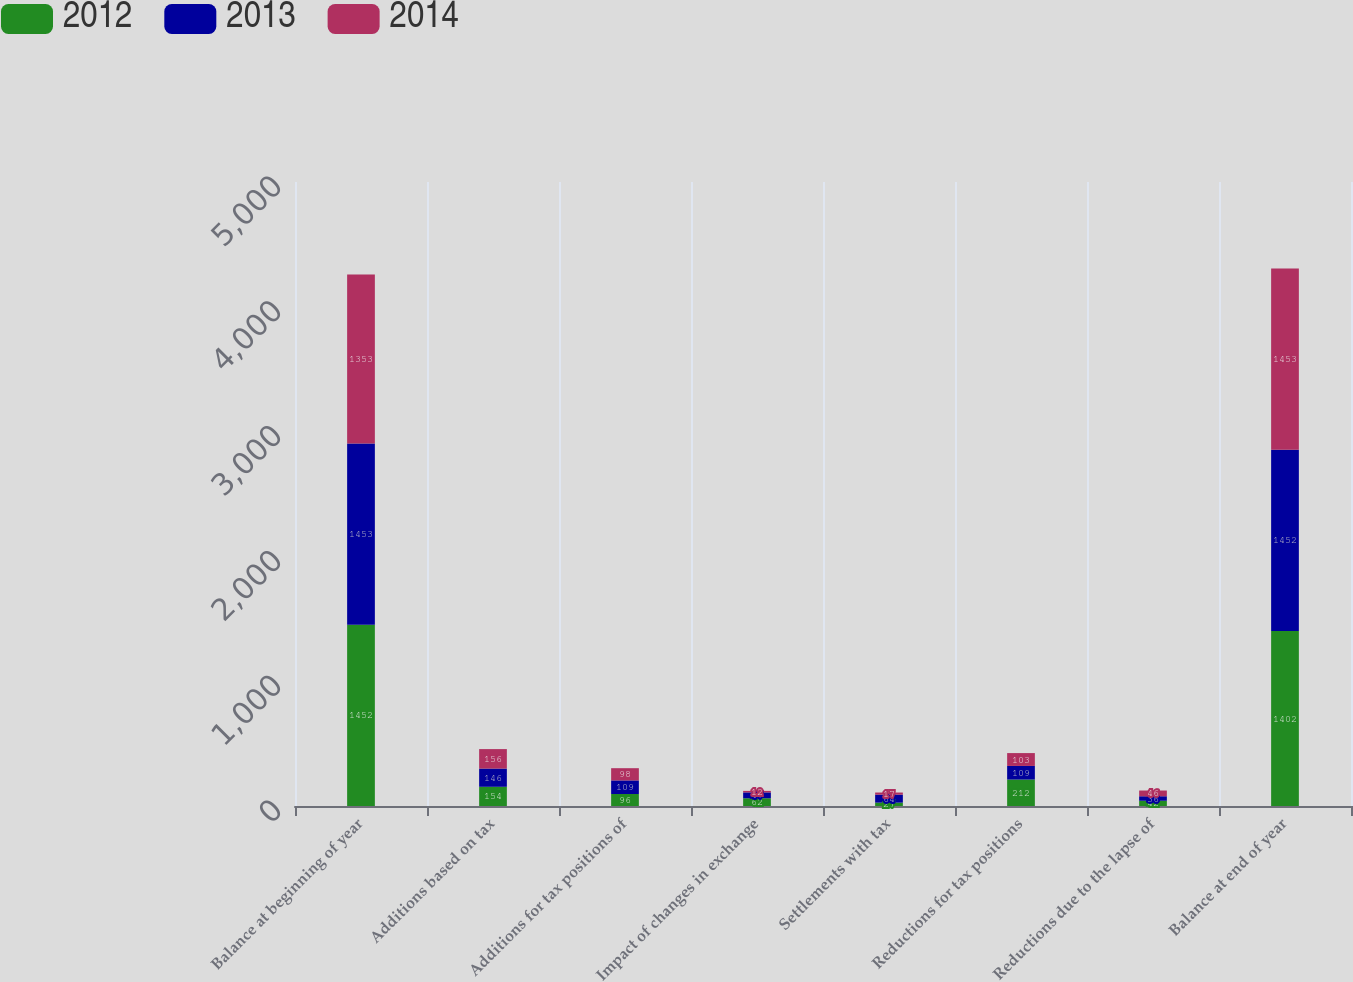Convert chart to OTSL. <chart><loc_0><loc_0><loc_500><loc_500><stacked_bar_chart><ecel><fcel>Balance at beginning of year<fcel>Additions based on tax<fcel>Additions for tax positions of<fcel>Impact of changes in exchange<fcel>Settlements with tax<fcel>Reductions for tax positions<fcel>Reductions due to the lapse of<fcel>Balance at end of year<nl><fcel>2012<fcel>1452<fcel>154<fcel>96<fcel>62<fcel>27<fcel>212<fcel>42<fcel>1402<nl><fcel>2013<fcel>1453<fcel>146<fcel>109<fcel>47<fcel>64<fcel>109<fcel>36<fcel>1452<nl><fcel>2014<fcel>1353<fcel>156<fcel>98<fcel>12<fcel>17<fcel>103<fcel>46<fcel>1453<nl></chart> 